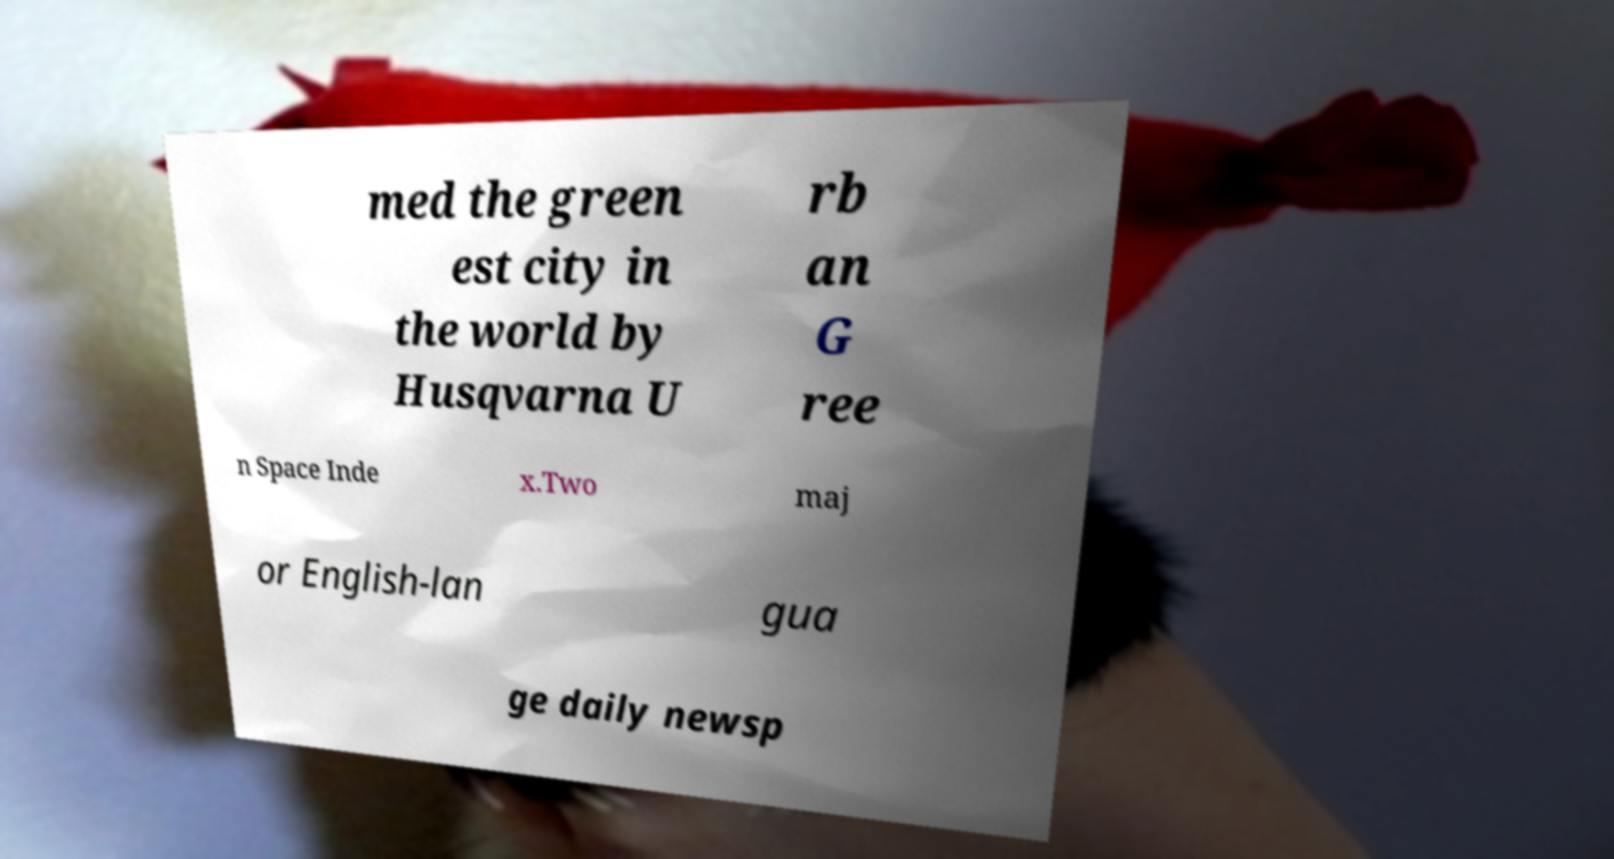Can you accurately transcribe the text from the provided image for me? med the green est city in the world by Husqvarna U rb an G ree n Space Inde x.Two maj or English-lan gua ge daily newsp 